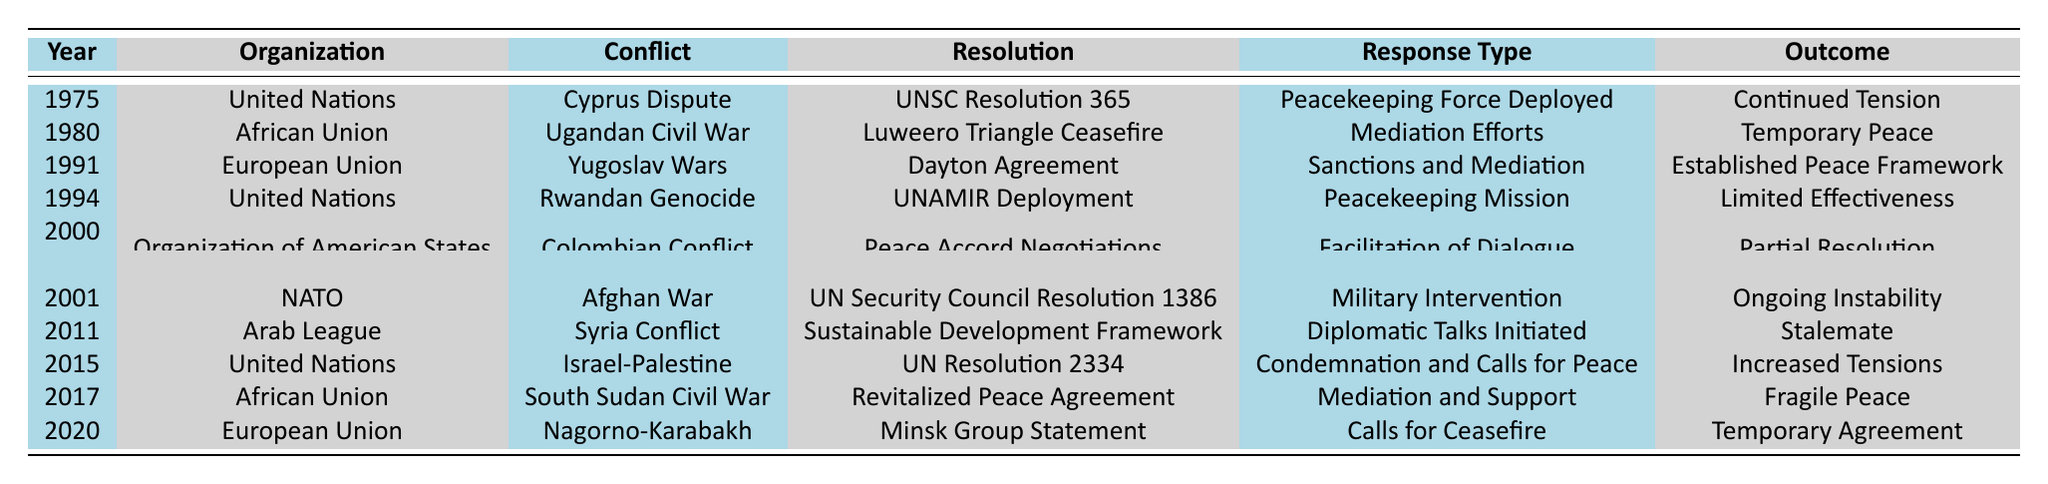What year did the United Nations respond to the Cyprus Dispute? The table indicates that the United Nations responded to the Cyprus Dispute in the year 1975.
Answer: 1975 Which organization mediated efforts during the Ugandan Civil War? The African Union is listed as the organization that engaged in mediation efforts during the Ugandan Civil War in 1980.
Answer: African Union How many conflicts prompted a peacekeeping response from the United Nations according to the table? Two conflicts prompted peacekeeping responses from the United Nations: the Cyprus Dispute in 1975 and the Rwandan Genocide in 1994.
Answer: 2 What was the outcome of the response to the Syrian Conflict by the Arab League? According to the table, the response to the Syrian Conflict by the Arab League resulted in a stalemate.
Answer: Stalemate Which response type was associated with the resolution for the South Sudan Civil War in 2017? The response type associated with the South Sudan Civil War resolution is mediation and support, as indicated in the table.
Answer: Mediation and Support What was the overall trend of outcomes for interventions after 2010 based on the table? The outcomes after 2010 show a trend of either ongoing instability or increased tensions, with no definitive resolutions achieved for conflicts such as Syria and Israel-Palestine.
Answer: Ongoing instability or increased tensions In which year did the European Union facilitate a negotiation for peace in the context of the Colombian Conflict? The table states that the European Union facilitated peace accord negotiations in the year 2000 concerning the Colombian Conflict.
Answer: 2000 Which organization experienced a notable limited effectiveness in their peacekeeping mission in 1994? The United Nations experienced limited effectiveness in their peacekeeping mission concerning the Rwandan Genocide in 1994.
Answer: United Nations How often did military intervention appear as a response type in the table? Military intervention appeared once as a response for the Afghan War by NATO in 2001, according to the table.
Answer: Once Was there a response to the Nagorno-Karabakh conflict by the African Union? No, the table does not indicate any response to the Nagorno-Karabakh conflict by the African Union; it states the European Union responded instead.
Answer: No Which conflict had a response characterized as "Calls for Ceasefire" and in what year? The conflict that had a response characterized as "Calls for Ceasefire" is the Nagorno-Karabakh conflict, which took place in the year 2020.
Answer: Nagorno-Karabakh, 2020 If you compare the outcomes before and after 2000, which time period seems to show more effective resolutions? Comparing the outcomes, the earlier period (1970-2000) shows some reasonable resolutions like the established peace framework in 1991, while the later period (2001-2020) indicates ongoing instability and stalemates, suggesting that resolutions might be less effective after 2000.
Answer: Earlier period shows more effective resolutions 